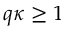Convert formula to latex. <formula><loc_0><loc_0><loc_500><loc_500>q \kappa \geq 1</formula> 